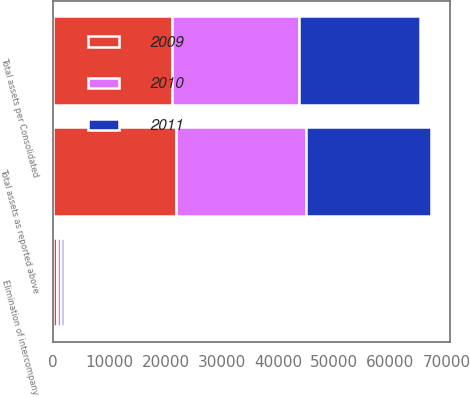Convert chart. <chart><loc_0><loc_0><loc_500><loc_500><stacked_bar_chart><ecel><fcel>Total assets as reported above<fcel>Elimination of intercompany<fcel>Total assets per Consolidated<nl><fcel>2010<fcel>23241<fcel>672<fcel>22569<nl><fcel>2011<fcel>22169<fcel>693<fcel>21476<nl><fcel>2009<fcel>21801<fcel>647<fcel>21154<nl></chart> 